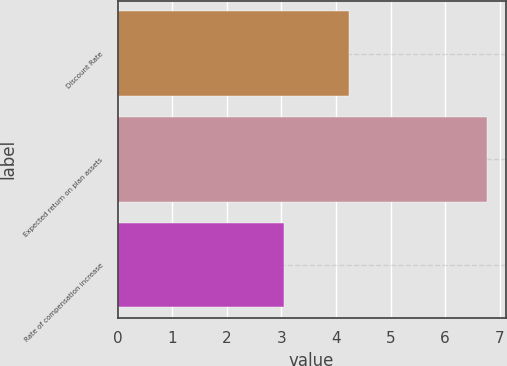Convert chart. <chart><loc_0><loc_0><loc_500><loc_500><bar_chart><fcel>Discount Rate<fcel>Expected return on plan assets<fcel>Rate of compensation increase<nl><fcel>4.24<fcel>6.77<fcel>3.05<nl></chart> 